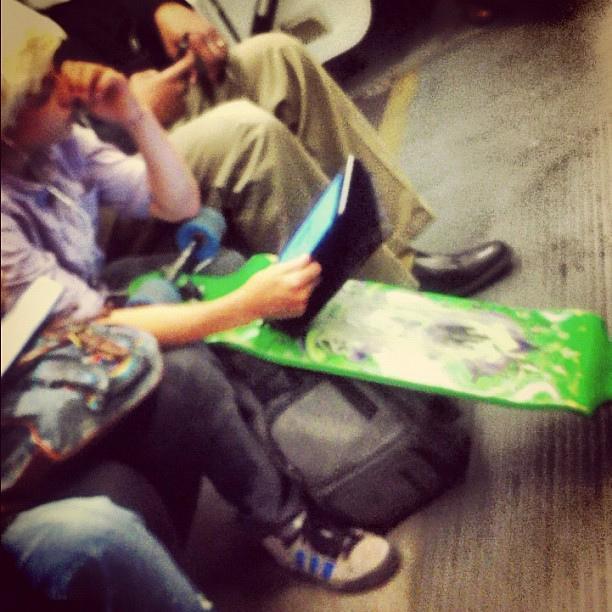What device is the boy holding?
Make your selection from the four choices given to correctly answer the question.
Options: Television, smartphone, laptop, tablet. Tablet. 